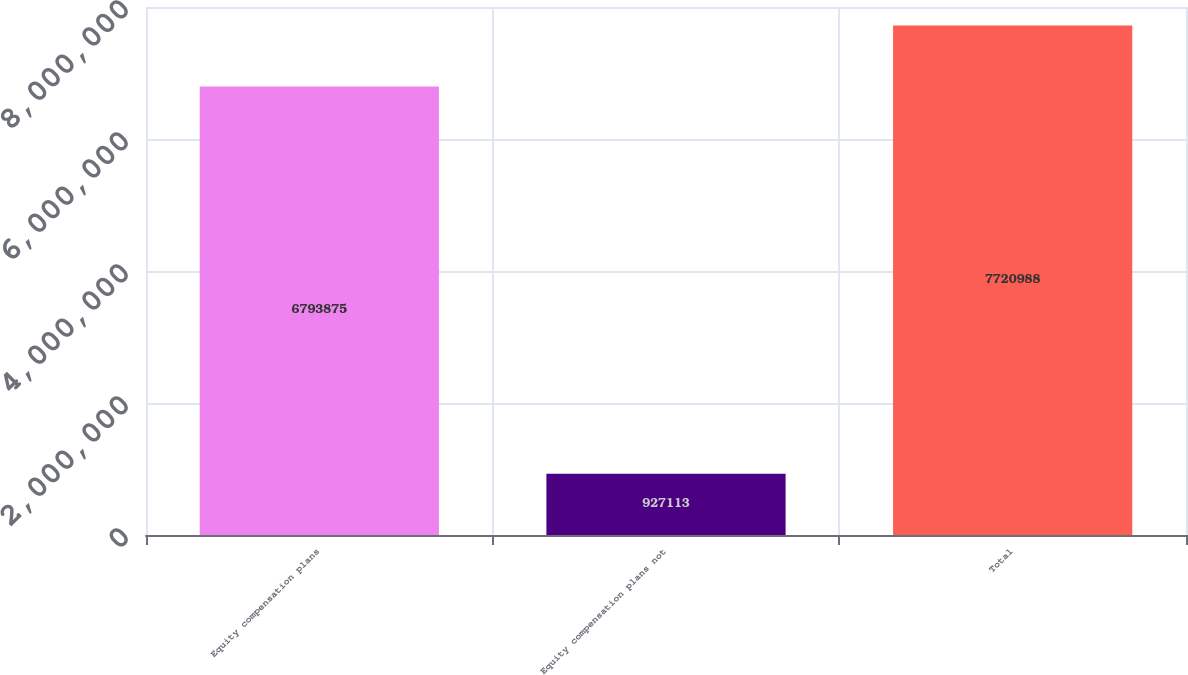<chart> <loc_0><loc_0><loc_500><loc_500><bar_chart><fcel>Equity compensation plans<fcel>Equity compensation plans not<fcel>Total<nl><fcel>6.79388e+06<fcel>927113<fcel>7.72099e+06<nl></chart> 